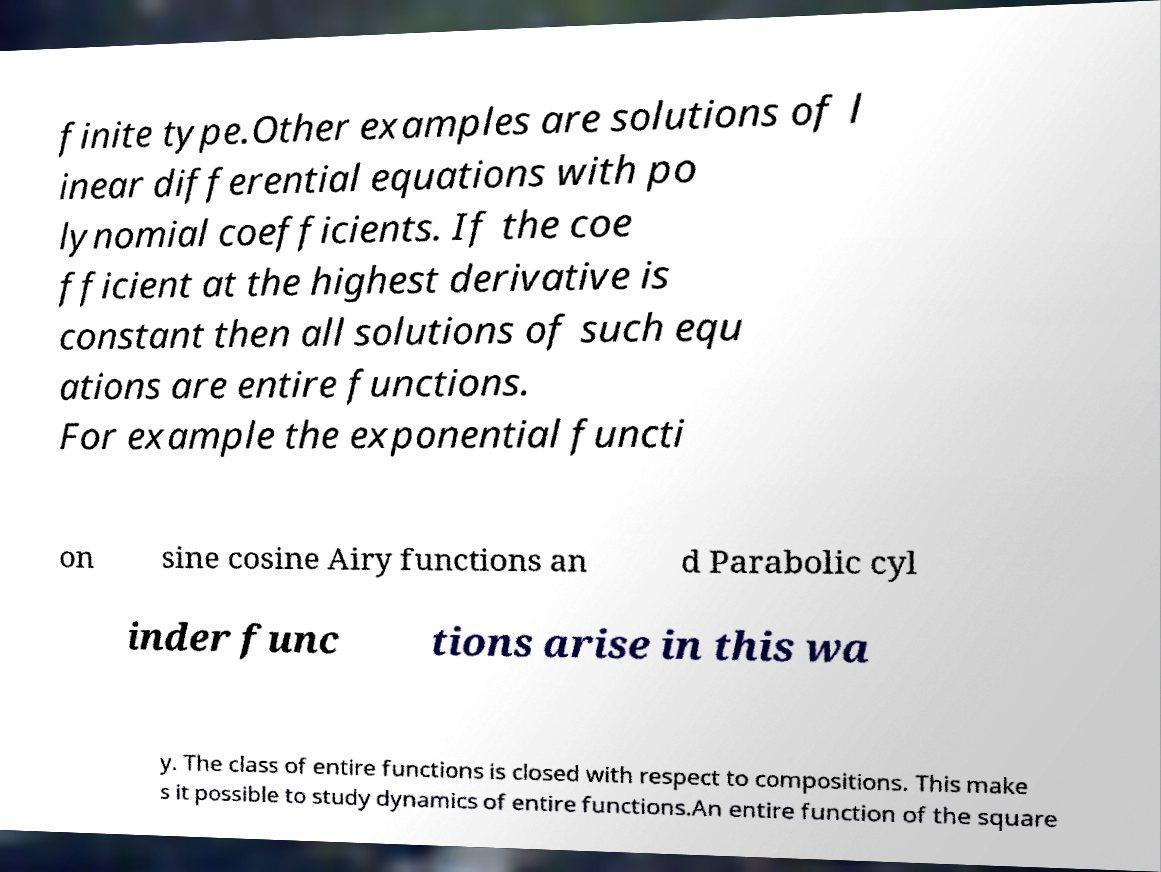Can you accurately transcribe the text from the provided image for me? finite type.Other examples are solutions of l inear differential equations with po lynomial coefficients. If the coe fficient at the highest derivative is constant then all solutions of such equ ations are entire functions. For example the exponential functi on sine cosine Airy functions an d Parabolic cyl inder func tions arise in this wa y. The class of entire functions is closed with respect to compositions. This make s it possible to study dynamics of entire functions.An entire function of the square 